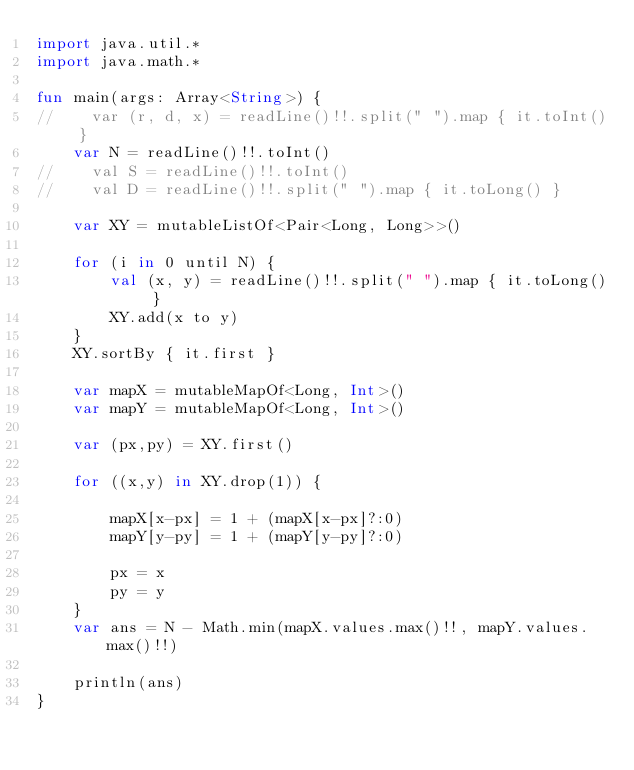Convert code to text. <code><loc_0><loc_0><loc_500><loc_500><_Kotlin_>import java.util.*
import java.math.*

fun main(args: Array<String>) {
//    var (r, d, x) = readLine()!!.split(" ").map { it.toInt() }
    var N = readLine()!!.toInt()
//    val S = readLine()!!.toInt()
//    val D = readLine()!!.split(" ").map { it.toLong() }

    var XY = mutableListOf<Pair<Long, Long>>()

    for (i in 0 until N) {
        val (x, y) = readLine()!!.split(" ").map { it.toLong() }
        XY.add(x to y)
    }
    XY.sortBy { it.first }

    var mapX = mutableMapOf<Long, Int>()
    var mapY = mutableMapOf<Long, Int>()

    var (px,py) = XY.first()

    for ((x,y) in XY.drop(1)) {

        mapX[x-px] = 1 + (mapX[x-px]?:0)
        mapY[y-py] = 1 + (mapY[y-py]?:0)

        px = x
        py = y
    }
    var ans = N - Math.min(mapX.values.max()!!, mapY.values.max()!!)

    println(ans)
}
</code> 